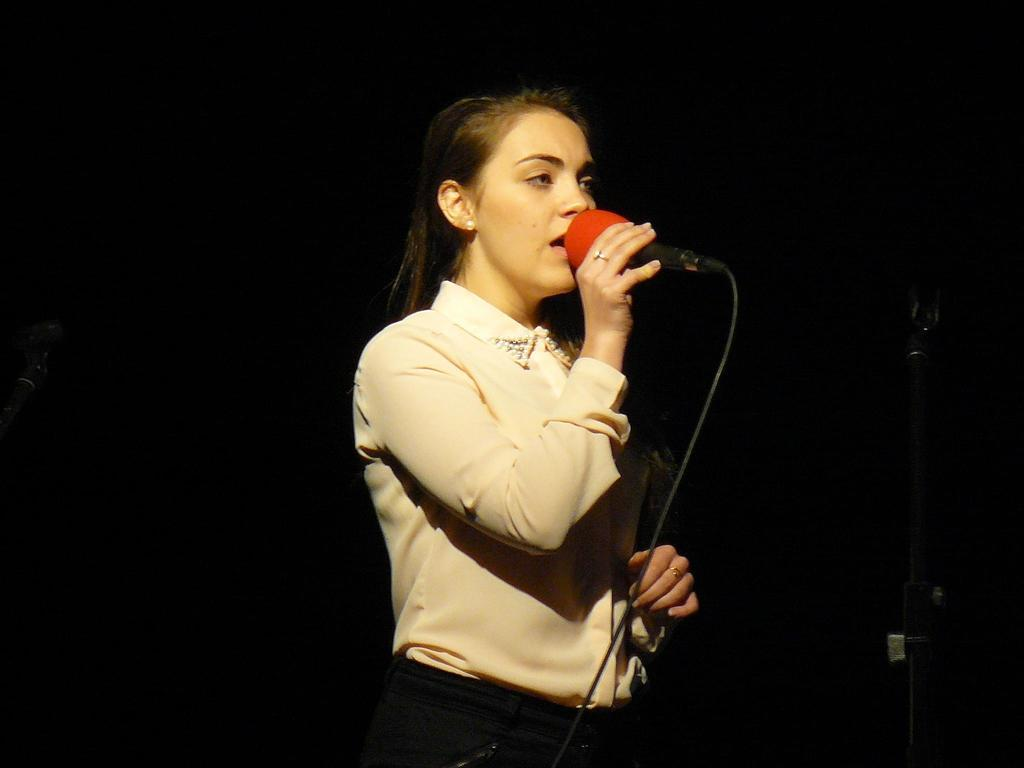What is the main subject of the image? There is a person in the image. What is the person wearing? The person is wearing a shirt. What is the person doing in the image? The person is standing and holding a mic in her hand. What can be observed about the background of the image? The background of the image is dark. What type of arithmetic problem is the person solving in the image? There is no arithmetic problem present in the image; the person is holding a mic in her hand. Can you tell me how many porters are assisting the person in the image? There are no porters present in the image; the person is standing alone. 